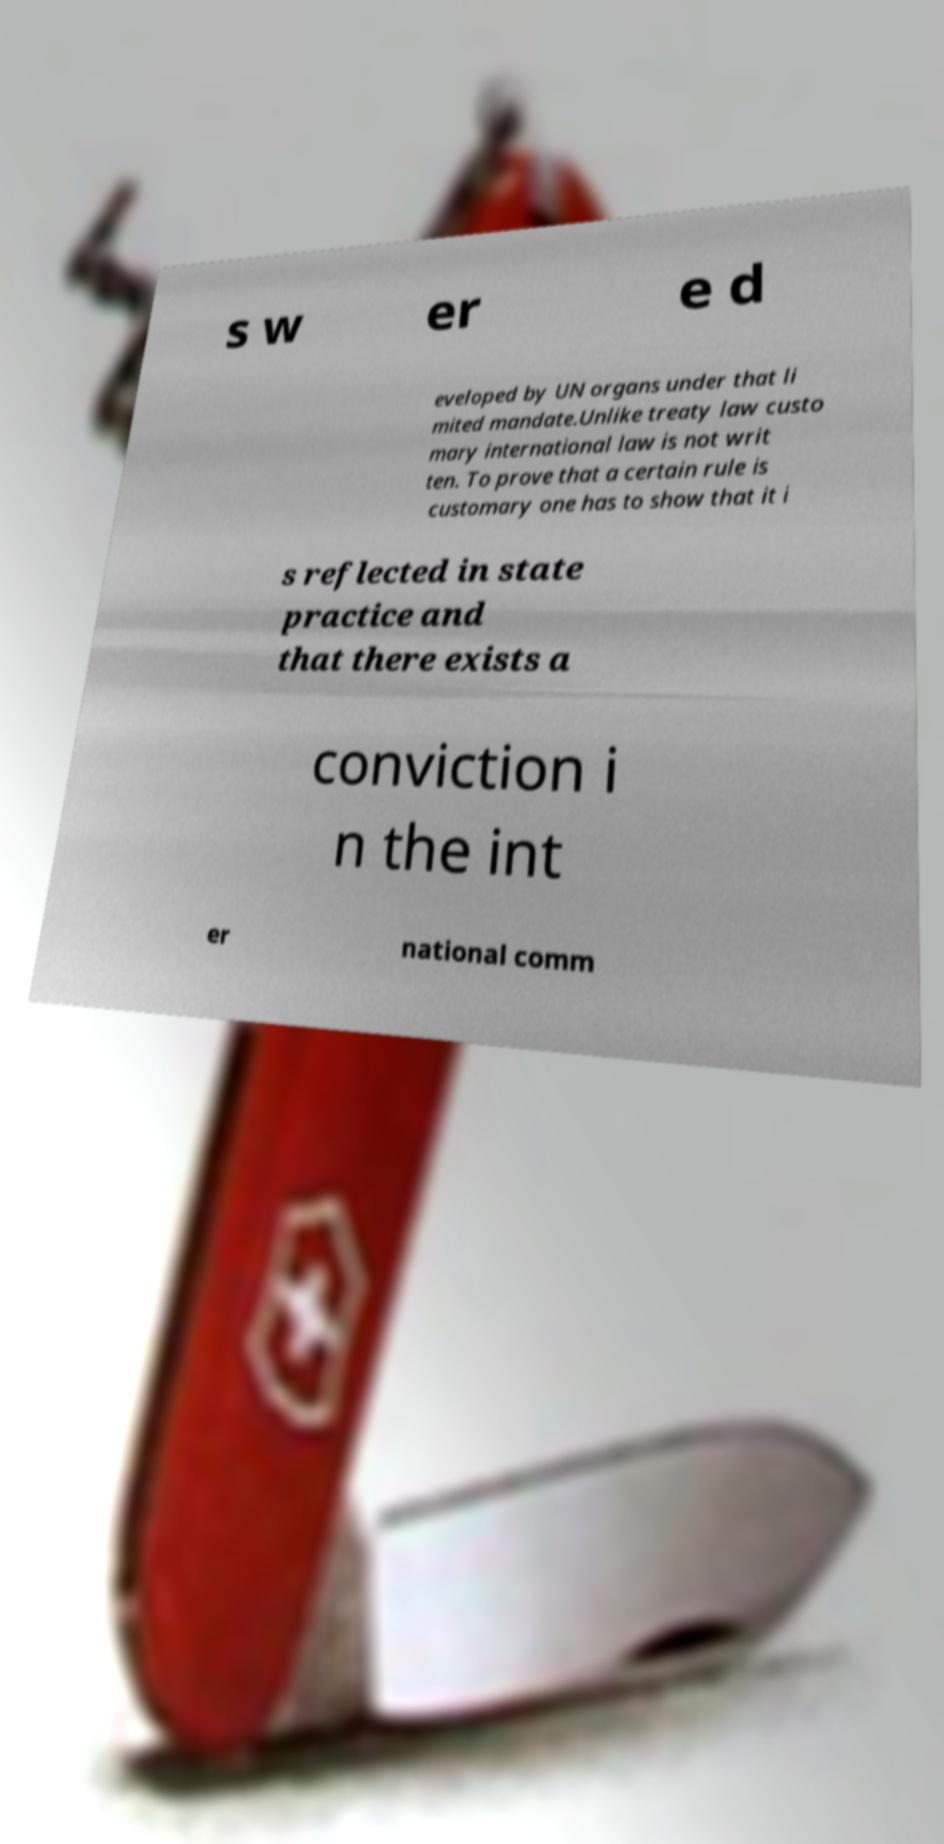Please read and relay the text visible in this image. What does it say? s w er e d eveloped by UN organs under that li mited mandate.Unlike treaty law custo mary international law is not writ ten. To prove that a certain rule is customary one has to show that it i s reflected in state practice and that there exists a conviction i n the int er national comm 